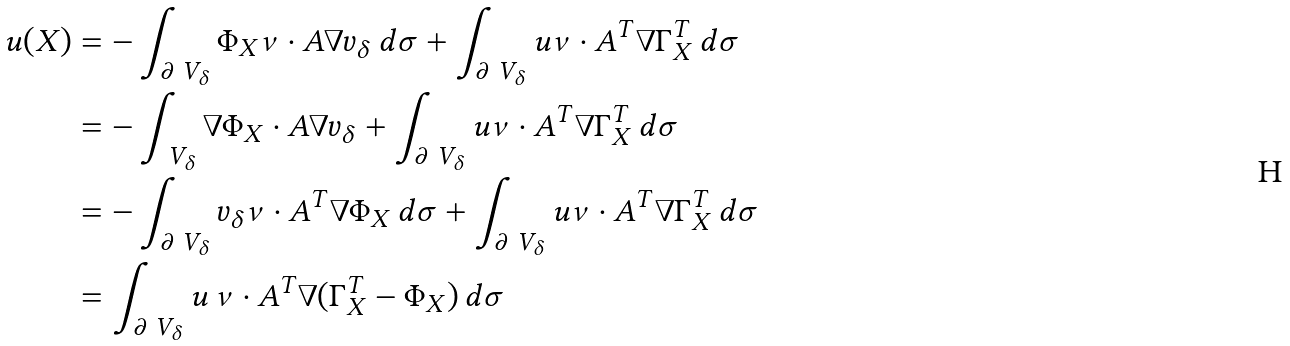Convert formula to latex. <formula><loc_0><loc_0><loc_500><loc_500>u ( X ) & = - \int _ { \partial \ V _ { \delta } } \Phi _ { X } \nu \cdot A \nabla v _ { \delta } \, d \sigma + \int _ { \partial \ V _ { \delta } } u \nu \cdot A ^ { T } \nabla \Gamma _ { X } ^ { T } \, d \sigma \\ & = - \int _ { \ V _ { \delta } } \nabla \Phi _ { X } \cdot A \nabla v _ { \delta } + \int _ { \partial \ V _ { \delta } } u \nu \cdot A ^ { T } \nabla \Gamma _ { X } ^ { T } \, d \sigma \\ & = - \int _ { \partial \ V _ { \delta } } v _ { \delta } \nu \cdot A ^ { T } \nabla \Phi _ { X } \, d \sigma + \int _ { \partial \ V _ { \delta } } u \nu \cdot A ^ { T } \nabla \Gamma _ { X } ^ { T } \, d \sigma \\ & = \int _ { \partial \ V _ { \delta } } u \, \nu \cdot A ^ { T } \nabla ( \Gamma _ { X } ^ { T } - \Phi _ { X } ) \, d \sigma</formula> 